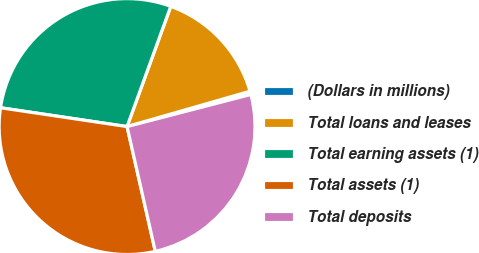Convert chart to OTSL. <chart><loc_0><loc_0><loc_500><loc_500><pie_chart><fcel>(Dollars in millions)<fcel>Total loans and leases<fcel>Total earning assets (1)<fcel>Total assets (1)<fcel>Total deposits<nl><fcel>0.41%<fcel>15.0%<fcel>28.2%<fcel>30.89%<fcel>25.5%<nl></chart> 